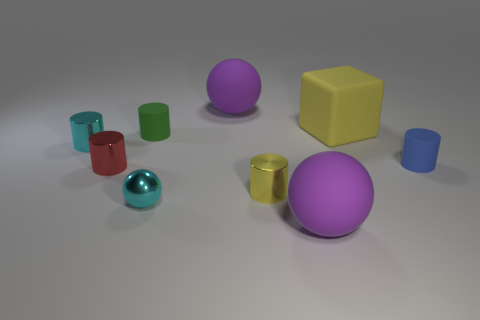Is there any other thing that is the same shape as the big yellow thing?
Your answer should be compact. No. Is the yellow rubber object the same shape as the small green matte object?
Give a very brief answer. No. What number of cylinders are brown things or small metal things?
Provide a short and direct response. 3. There is another small cylinder that is made of the same material as the blue cylinder; what is its color?
Keep it short and to the point. Green. There is a purple rubber sphere in front of the red thing; is it the same size as the yellow rubber thing?
Make the answer very short. Yes. Do the red thing and the cyan object in front of the small yellow thing have the same material?
Make the answer very short. Yes. What is the color of the rubber object that is in front of the blue matte cylinder?
Offer a terse response. Purple. There is a metal object behind the tiny blue cylinder; is there a purple rubber ball in front of it?
Make the answer very short. Yes. Is the color of the tiny shiny thing behind the blue matte object the same as the tiny sphere on the right side of the green thing?
Your answer should be compact. Yes. There is a cyan ball; how many large purple spheres are in front of it?
Provide a short and direct response. 1. 